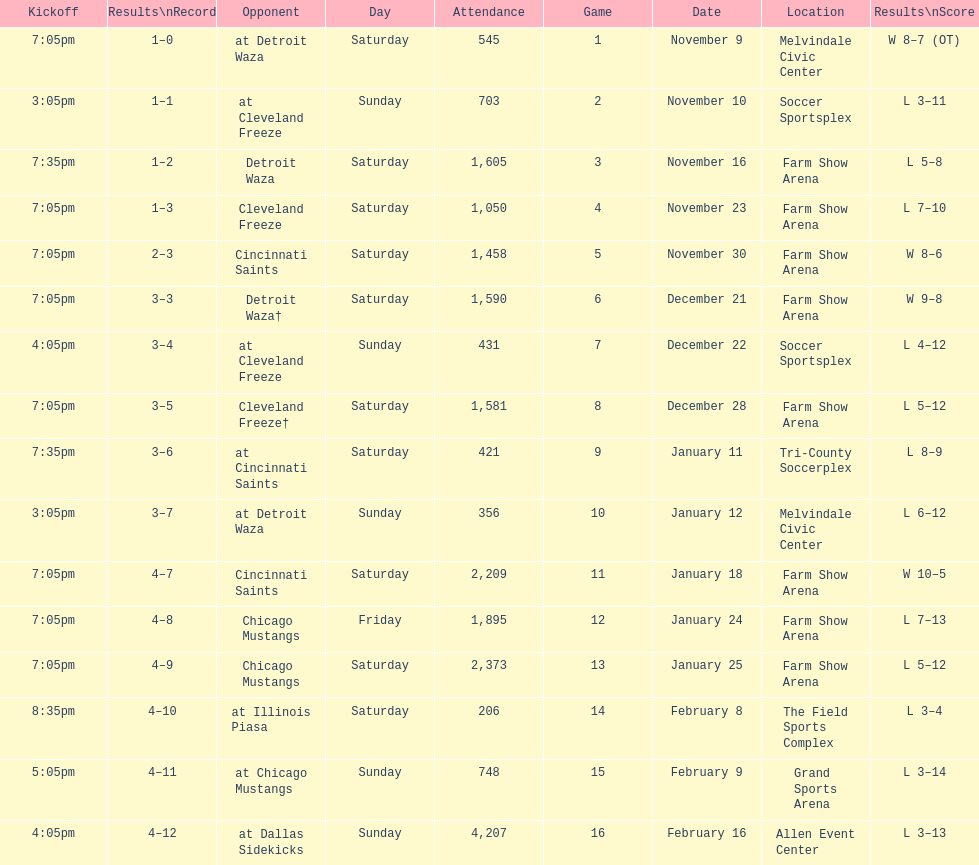Which opponent is listed after cleveland freeze in the table? Detroit Waza. 